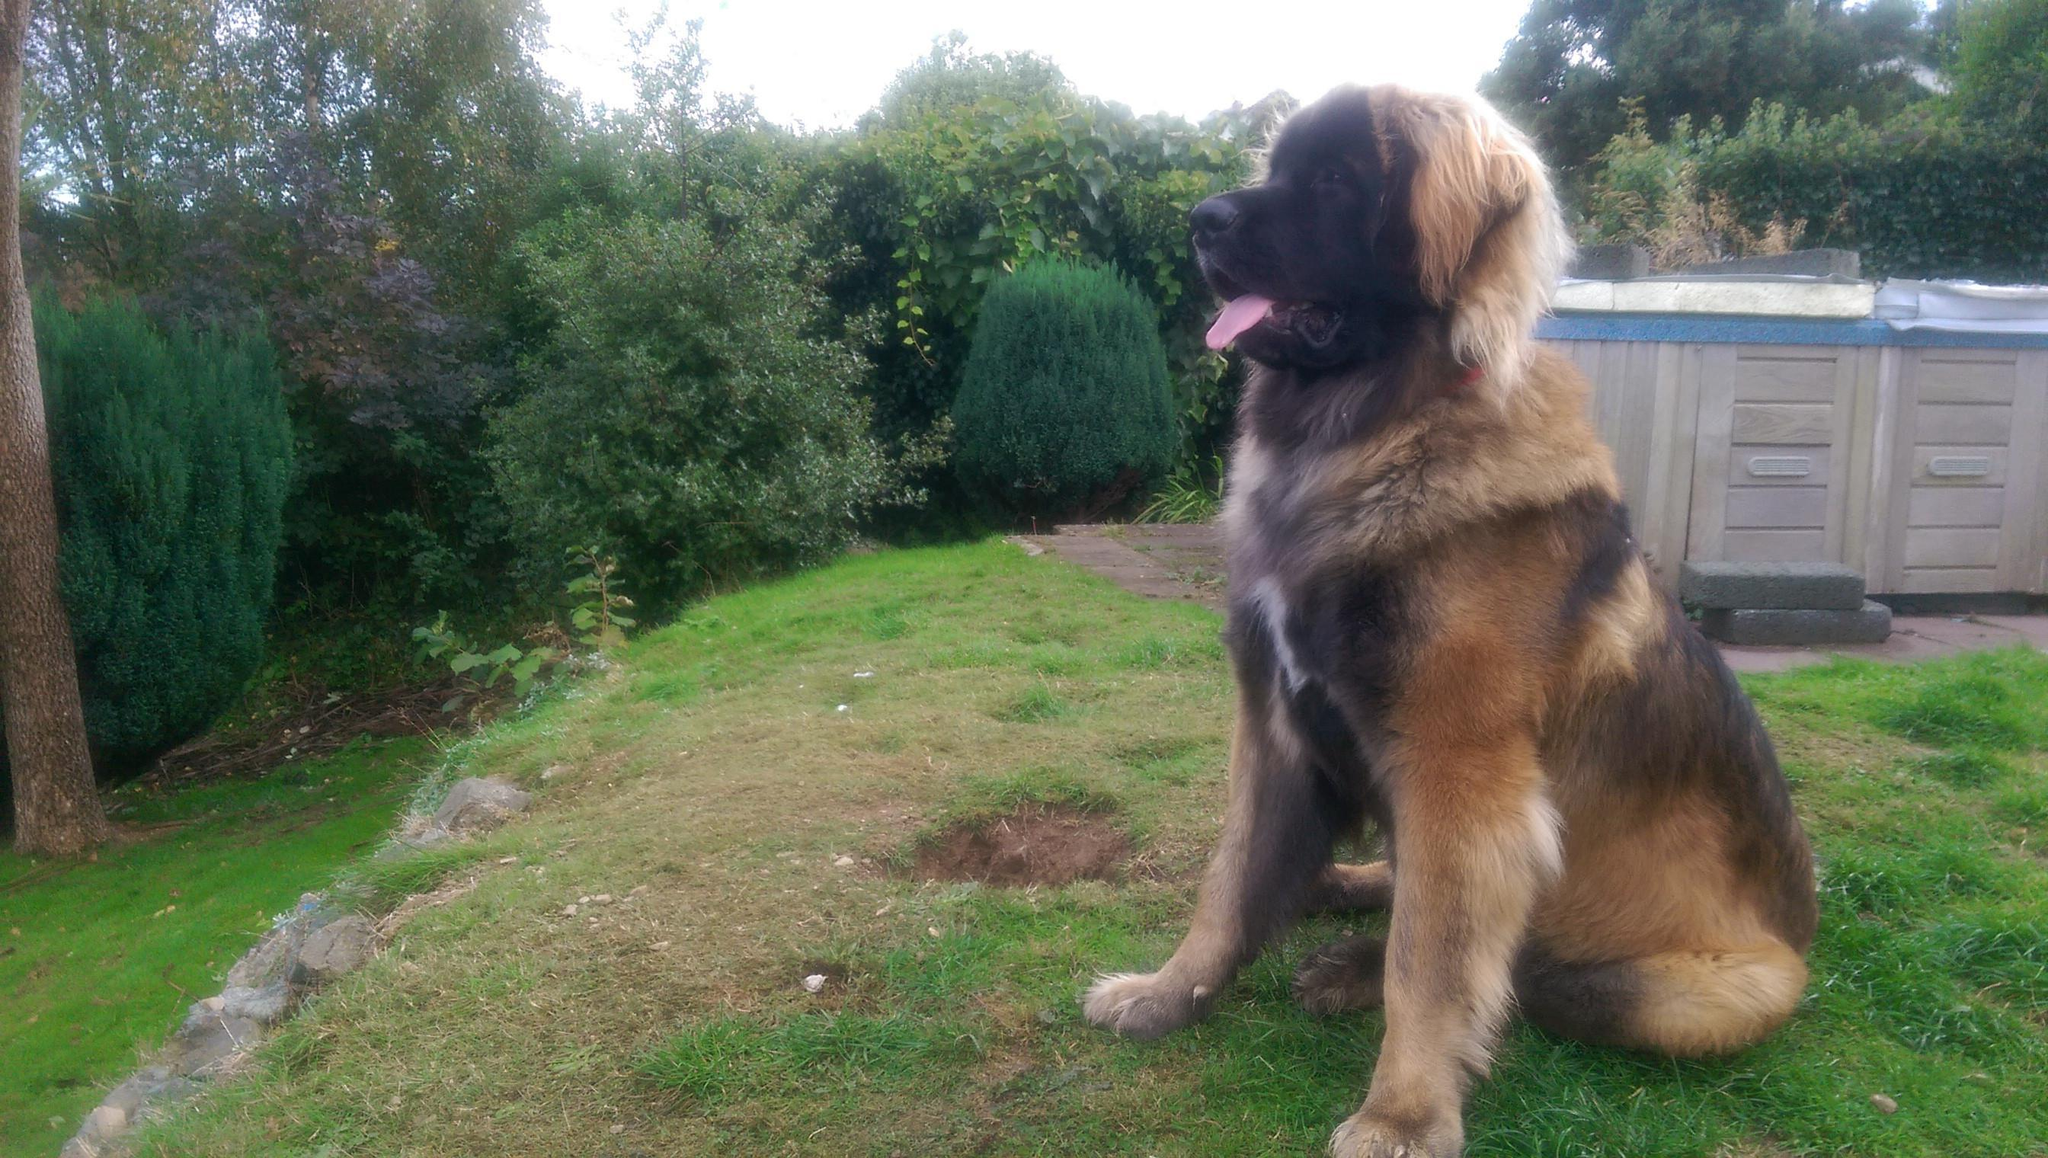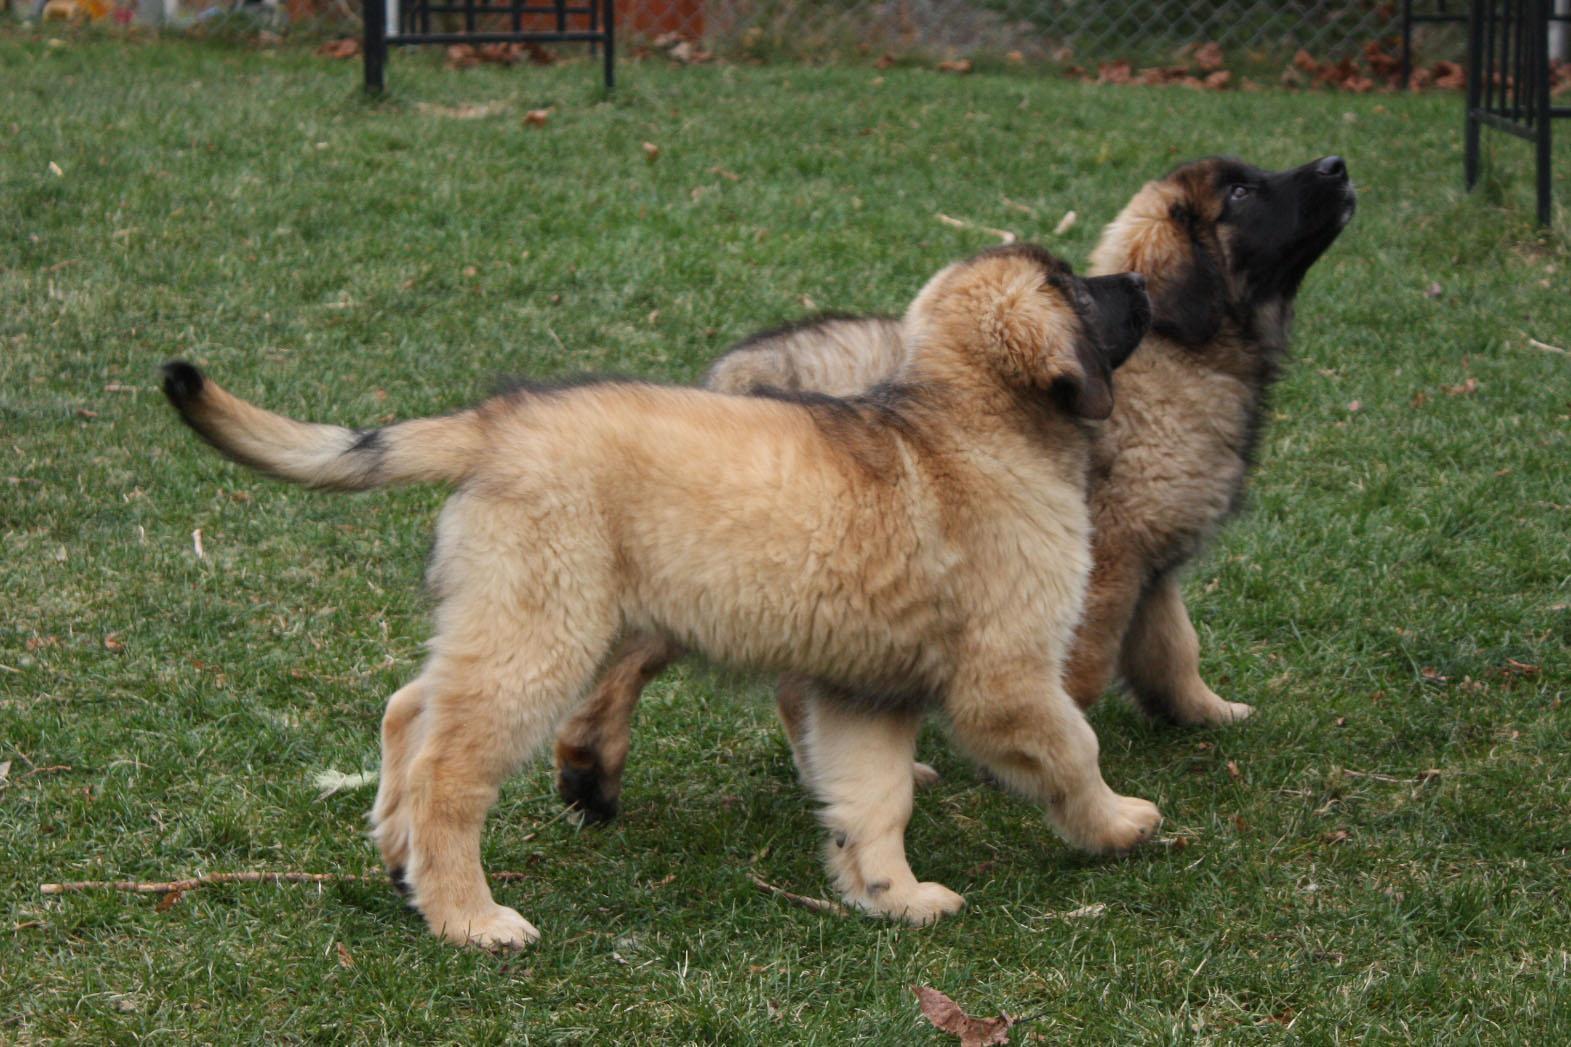The first image is the image on the left, the second image is the image on the right. Given the left and right images, does the statement "Only one dog is sitting in the grass." hold true? Answer yes or no. Yes. The first image is the image on the left, the second image is the image on the right. Assess this claim about the two images: "two puppies are atanding next to each other on the grass looking upward". Correct or not? Answer yes or no. Yes. 